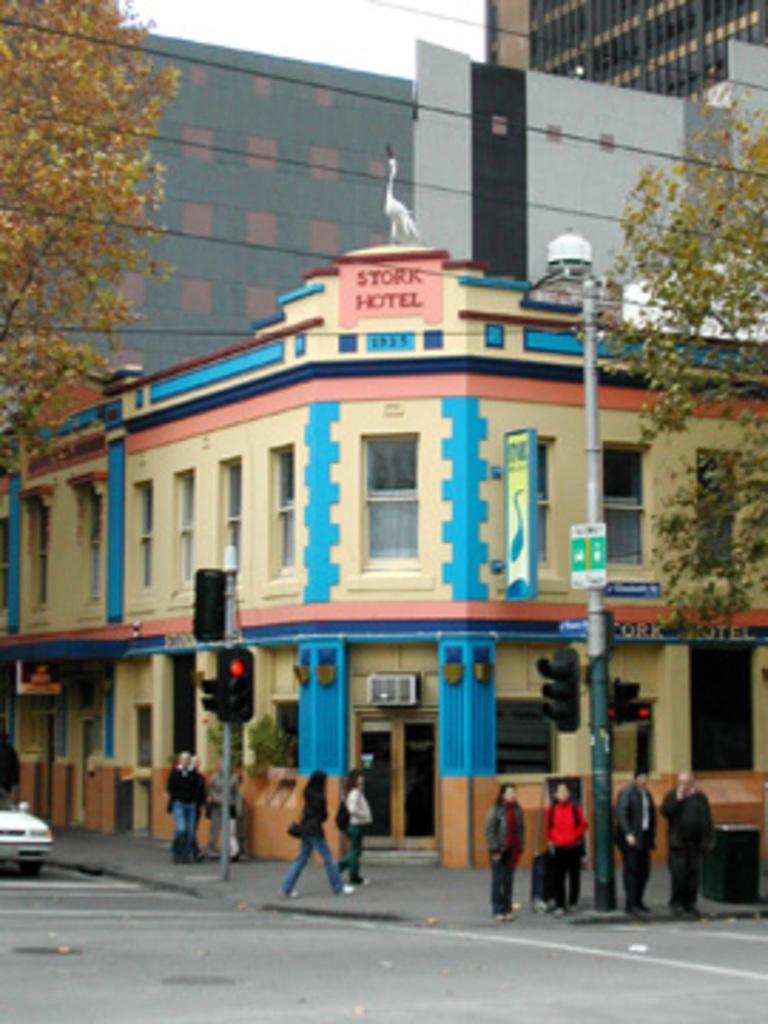Can you describe this image briefly? In this image I can see a white colored car on the road and I can see few persons standing on the sidewalk, a metal pole and few sign boards attached to it, a traffic signal pole and a building which is cream, blue and pink in color. In the background I can see few trees, few wires, few buildings, a bird which is white in color and the sky. 